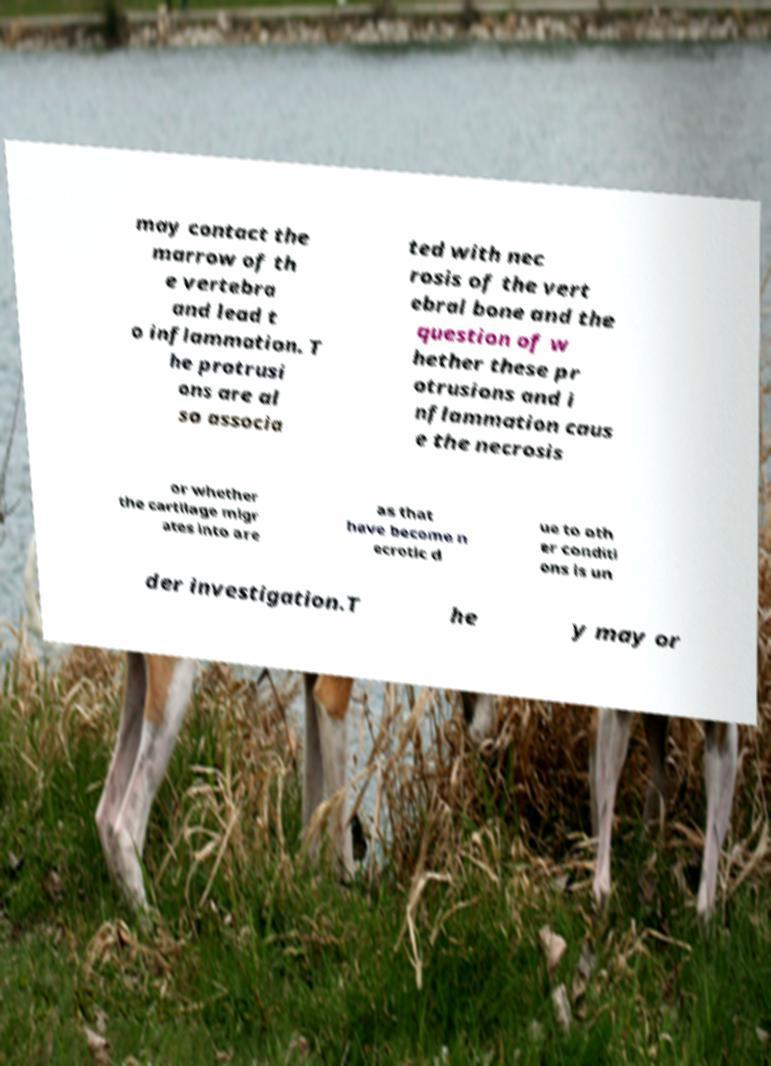What messages or text are displayed in this image? I need them in a readable, typed format. may contact the marrow of th e vertebra and lead t o inflammation. T he protrusi ons are al so associa ted with nec rosis of the vert ebral bone and the question of w hether these pr otrusions and i nflammation caus e the necrosis or whether the cartilage migr ates into are as that have become n ecrotic d ue to oth er conditi ons is un der investigation.T he y may or 